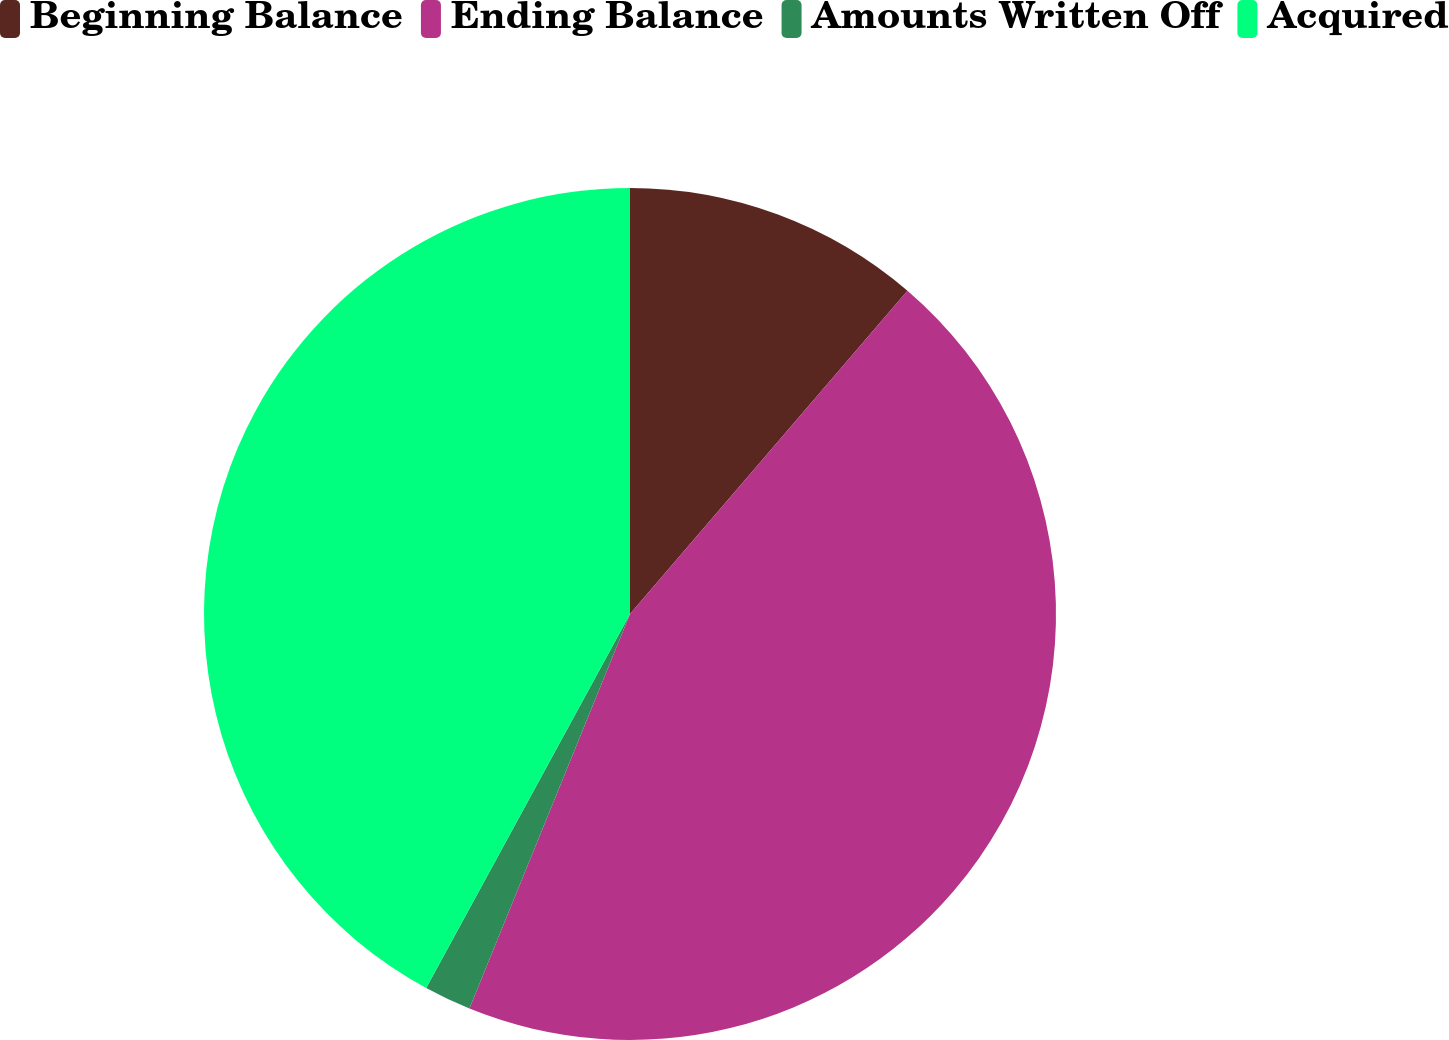Convert chart to OTSL. <chart><loc_0><loc_0><loc_500><loc_500><pie_chart><fcel>Beginning Balance<fcel>Ending Balance<fcel>Amounts Written Off<fcel>Acquired<nl><fcel>11.29%<fcel>44.86%<fcel>1.79%<fcel>42.06%<nl></chart> 